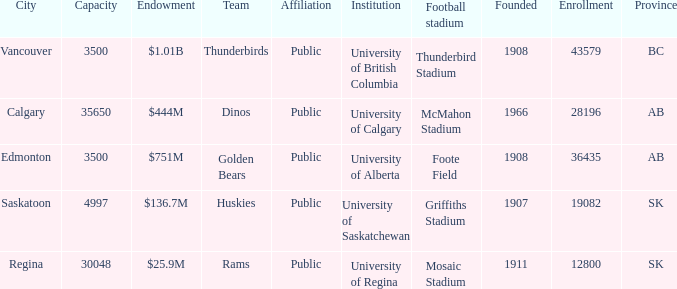Which institution has an endowment of $25.9m? University of Regina. 